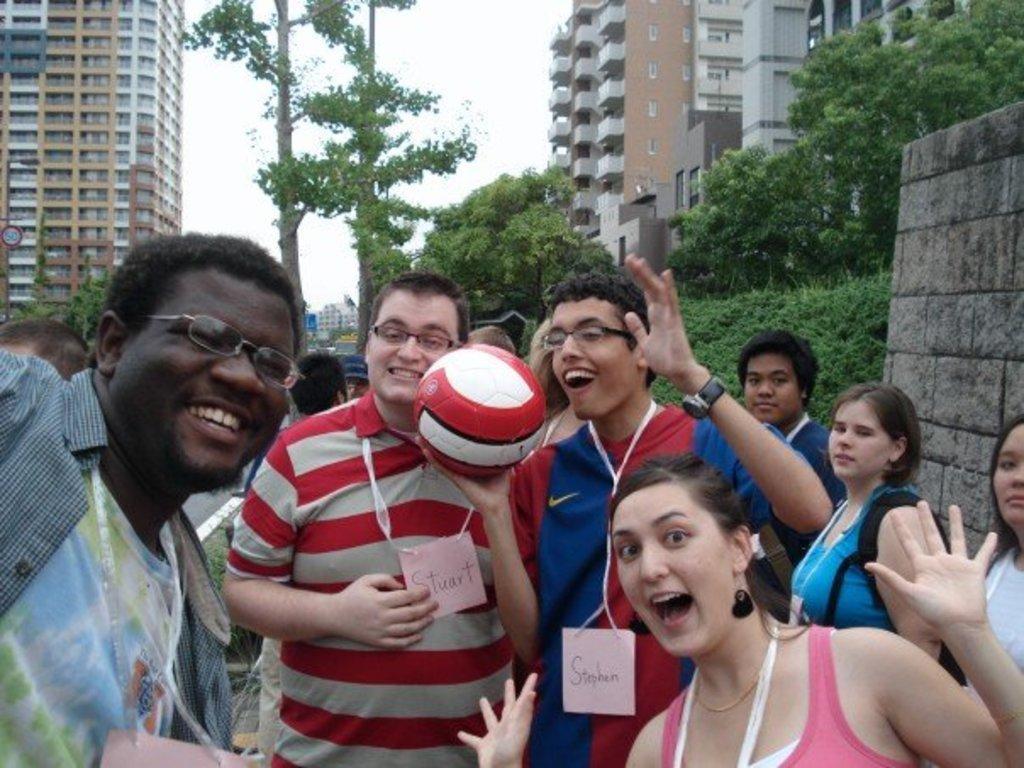How would you summarize this image in a sentence or two? In this image I can see the group of people standing. Among them one person is holding the ball. In the background there are trees,building and the sky. 